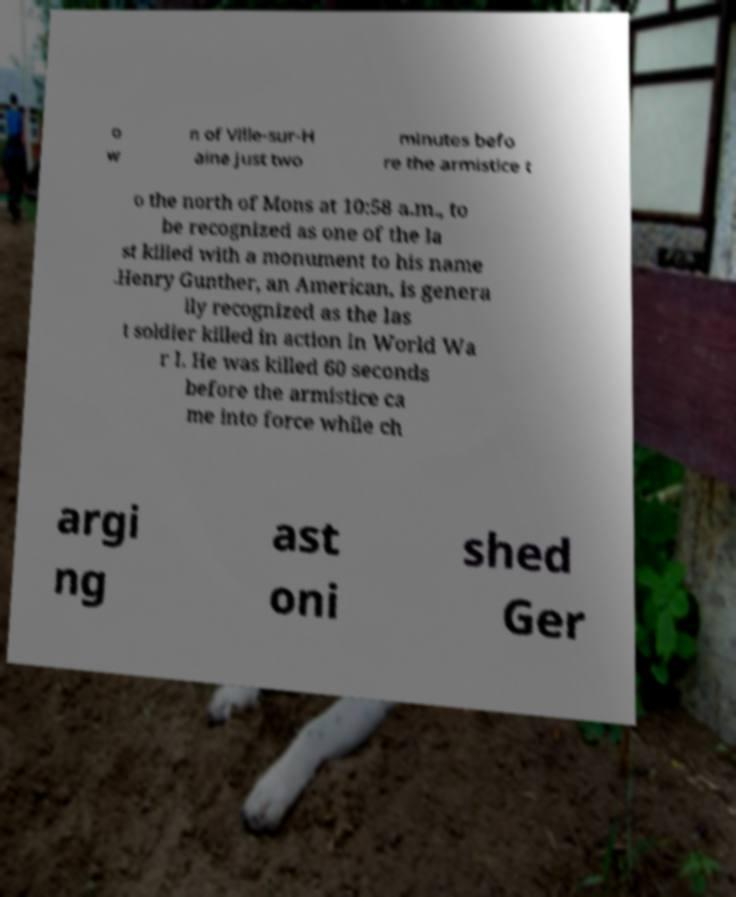I need the written content from this picture converted into text. Can you do that? o w n of Ville-sur-H aine just two minutes befo re the armistice t o the north of Mons at 10:58 a.m., to be recognized as one of the la st killed with a monument to his name .Henry Gunther, an American, is genera lly recognized as the las t soldier killed in action in World Wa r I. He was killed 60 seconds before the armistice ca me into force while ch argi ng ast oni shed Ger 